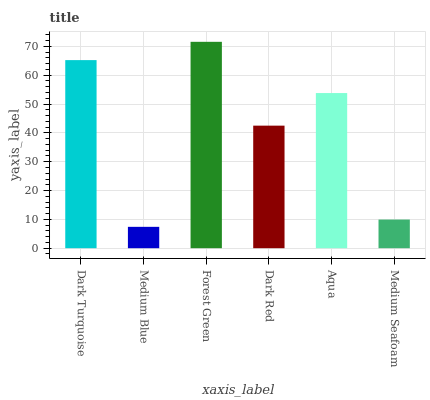Is Medium Blue the minimum?
Answer yes or no. Yes. Is Forest Green the maximum?
Answer yes or no. Yes. Is Forest Green the minimum?
Answer yes or no. No. Is Medium Blue the maximum?
Answer yes or no. No. Is Forest Green greater than Medium Blue?
Answer yes or no. Yes. Is Medium Blue less than Forest Green?
Answer yes or no. Yes. Is Medium Blue greater than Forest Green?
Answer yes or no. No. Is Forest Green less than Medium Blue?
Answer yes or no. No. Is Aqua the high median?
Answer yes or no. Yes. Is Dark Red the low median?
Answer yes or no. Yes. Is Medium Blue the high median?
Answer yes or no. No. Is Medium Blue the low median?
Answer yes or no. No. 